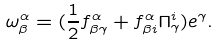<formula> <loc_0><loc_0><loc_500><loc_500>\omega _ { \beta } ^ { \alpha } = ( \frac { 1 } { 2 } f _ { \beta \gamma } ^ { \alpha } + f _ { \beta i } ^ { \alpha } \Pi _ { \gamma } ^ { i } ) e ^ { \gamma } .</formula> 